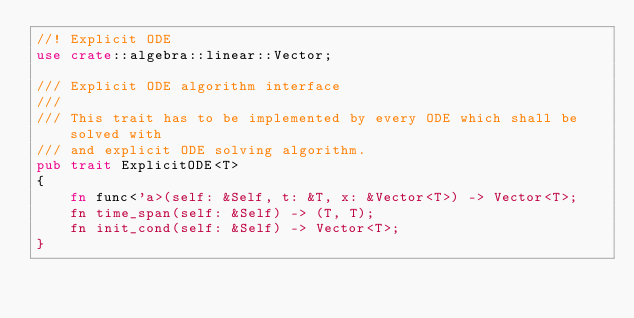Convert code to text. <code><loc_0><loc_0><loc_500><loc_500><_Rust_>//! Explicit ODE
use crate::algebra::linear::Vector;

/// Explicit ODE algorithm interface
///
/// This trait has to be implemented by every ODE which shall be solved with
/// and explicit ODE solving algorithm.
pub trait ExplicitODE<T>
{
    fn func<'a>(self: &Self, t: &T, x: &Vector<T>) -> Vector<T>;
    fn time_span(self: &Self) -> (T, T);
    fn init_cond(self: &Self) -> Vector<T>;
}
</code> 